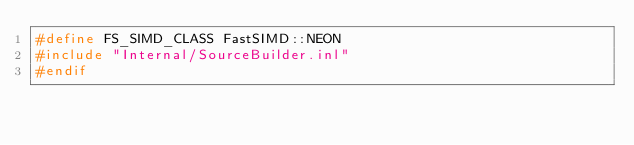<code> <loc_0><loc_0><loc_500><loc_500><_C++_>#define FS_SIMD_CLASS FastSIMD::NEON
#include "Internal/SourceBuilder.inl"
#endif</code> 